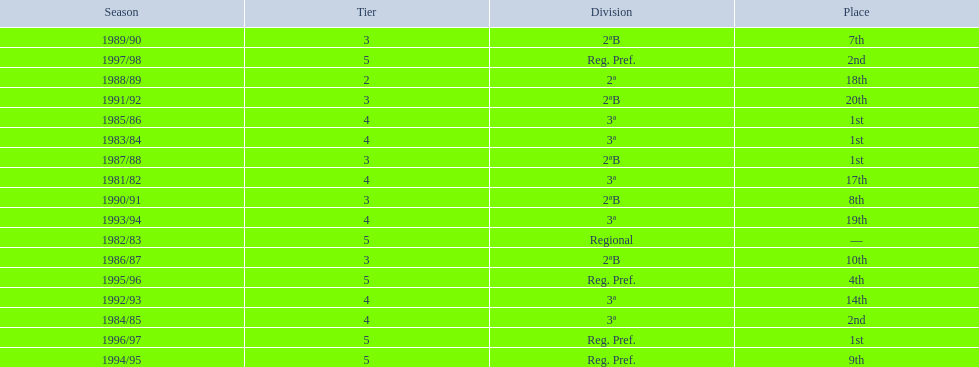What is the lowest place the team has come out? 20th. In what year did they come out in 20th place? 1991/92. 